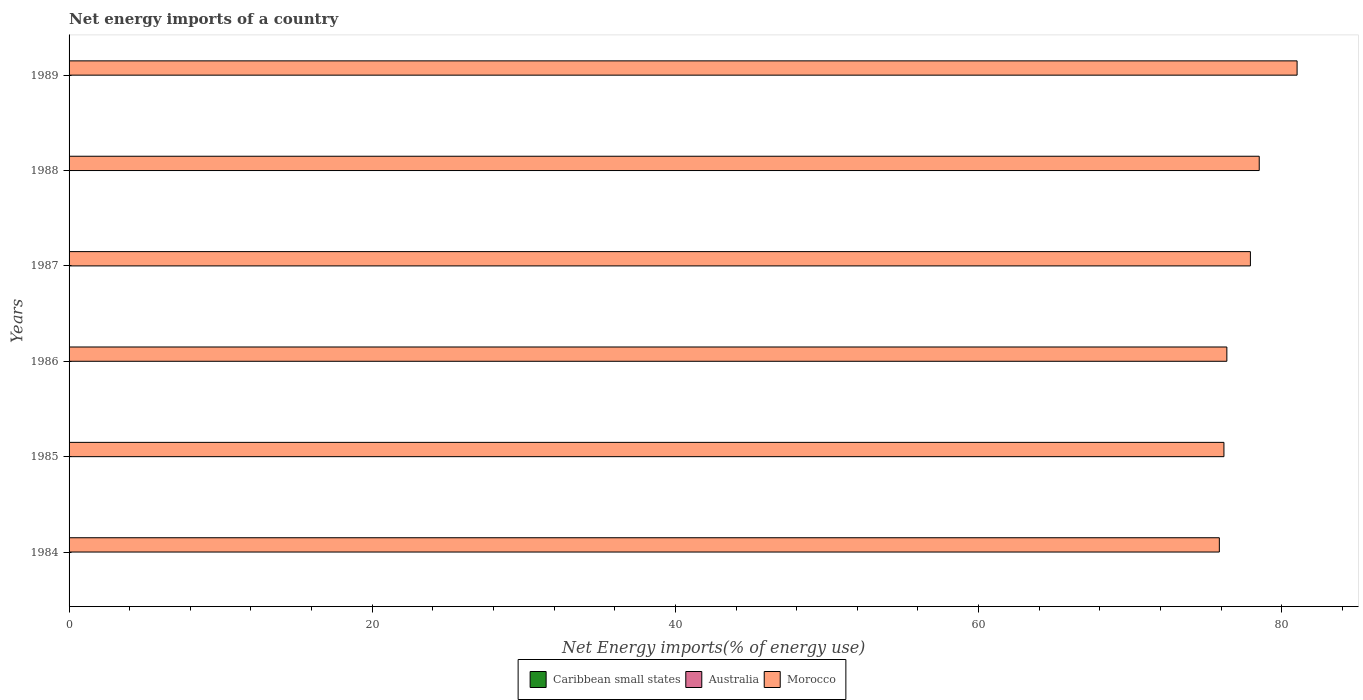How many different coloured bars are there?
Give a very brief answer. 1. Are the number of bars per tick equal to the number of legend labels?
Make the answer very short. No. Are the number of bars on each tick of the Y-axis equal?
Keep it short and to the point. Yes. How many bars are there on the 6th tick from the top?
Offer a terse response. 1. How many bars are there on the 4th tick from the bottom?
Keep it short and to the point. 1. What is the label of the 3rd group of bars from the top?
Give a very brief answer. 1987. What is the net energy imports in Caribbean small states in 1984?
Offer a terse response. 0. Across all years, what is the maximum net energy imports in Morocco?
Your answer should be compact. 81.02. Across all years, what is the minimum net energy imports in Australia?
Make the answer very short. 0. What is the total net energy imports in Australia in the graph?
Provide a succinct answer. 0. What is the difference between the net energy imports in Morocco in 1987 and that in 1988?
Provide a short and direct response. -0.58. What is the difference between the net energy imports in Caribbean small states in 1985 and the net energy imports in Australia in 1984?
Keep it short and to the point. 0. What is the average net energy imports in Australia per year?
Give a very brief answer. 0. What is the difference between the highest and the second highest net energy imports in Morocco?
Offer a terse response. 2.5. What is the difference between the highest and the lowest net energy imports in Morocco?
Your answer should be very brief. 5.13. In how many years, is the net energy imports in Morocco greater than the average net energy imports in Morocco taken over all years?
Offer a terse response. 3. How many years are there in the graph?
Make the answer very short. 6. What is the difference between two consecutive major ticks on the X-axis?
Your response must be concise. 20. What is the title of the graph?
Ensure brevity in your answer.  Net energy imports of a country. What is the label or title of the X-axis?
Your response must be concise. Net Energy imports(% of energy use). What is the Net Energy imports(% of energy use) of Caribbean small states in 1984?
Offer a very short reply. 0. What is the Net Energy imports(% of energy use) in Australia in 1984?
Make the answer very short. 0. What is the Net Energy imports(% of energy use) in Morocco in 1984?
Offer a terse response. 75.89. What is the Net Energy imports(% of energy use) in Morocco in 1985?
Give a very brief answer. 76.19. What is the Net Energy imports(% of energy use) in Morocco in 1986?
Offer a very short reply. 76.38. What is the Net Energy imports(% of energy use) in Caribbean small states in 1987?
Ensure brevity in your answer.  0. What is the Net Energy imports(% of energy use) in Australia in 1987?
Keep it short and to the point. 0. What is the Net Energy imports(% of energy use) in Morocco in 1987?
Provide a short and direct response. 77.94. What is the Net Energy imports(% of energy use) of Caribbean small states in 1988?
Provide a short and direct response. 0. What is the Net Energy imports(% of energy use) of Australia in 1988?
Your response must be concise. 0. What is the Net Energy imports(% of energy use) in Morocco in 1988?
Ensure brevity in your answer.  78.52. What is the Net Energy imports(% of energy use) in Caribbean small states in 1989?
Ensure brevity in your answer.  0. What is the Net Energy imports(% of energy use) of Morocco in 1989?
Offer a terse response. 81.02. Across all years, what is the maximum Net Energy imports(% of energy use) of Morocco?
Provide a short and direct response. 81.02. Across all years, what is the minimum Net Energy imports(% of energy use) of Morocco?
Provide a short and direct response. 75.89. What is the total Net Energy imports(% of energy use) in Caribbean small states in the graph?
Ensure brevity in your answer.  0. What is the total Net Energy imports(% of energy use) of Australia in the graph?
Your response must be concise. 0. What is the total Net Energy imports(% of energy use) in Morocco in the graph?
Your answer should be compact. 465.93. What is the difference between the Net Energy imports(% of energy use) of Morocco in 1984 and that in 1985?
Offer a very short reply. -0.3. What is the difference between the Net Energy imports(% of energy use) in Morocco in 1984 and that in 1986?
Your response must be concise. -0.5. What is the difference between the Net Energy imports(% of energy use) of Morocco in 1984 and that in 1987?
Provide a short and direct response. -2.05. What is the difference between the Net Energy imports(% of energy use) in Morocco in 1984 and that in 1988?
Provide a succinct answer. -2.63. What is the difference between the Net Energy imports(% of energy use) in Morocco in 1984 and that in 1989?
Provide a short and direct response. -5.13. What is the difference between the Net Energy imports(% of energy use) of Morocco in 1985 and that in 1986?
Give a very brief answer. -0.19. What is the difference between the Net Energy imports(% of energy use) of Morocco in 1985 and that in 1987?
Ensure brevity in your answer.  -1.75. What is the difference between the Net Energy imports(% of energy use) of Morocco in 1985 and that in 1988?
Provide a short and direct response. -2.33. What is the difference between the Net Energy imports(% of energy use) in Morocco in 1985 and that in 1989?
Provide a short and direct response. -4.83. What is the difference between the Net Energy imports(% of energy use) in Morocco in 1986 and that in 1987?
Your response must be concise. -1.55. What is the difference between the Net Energy imports(% of energy use) of Morocco in 1986 and that in 1988?
Offer a very short reply. -2.14. What is the difference between the Net Energy imports(% of energy use) of Morocco in 1986 and that in 1989?
Offer a terse response. -4.63. What is the difference between the Net Energy imports(% of energy use) in Morocco in 1987 and that in 1988?
Make the answer very short. -0.58. What is the difference between the Net Energy imports(% of energy use) in Morocco in 1987 and that in 1989?
Make the answer very short. -3.08. What is the difference between the Net Energy imports(% of energy use) of Morocco in 1988 and that in 1989?
Offer a very short reply. -2.5. What is the average Net Energy imports(% of energy use) in Caribbean small states per year?
Offer a terse response. 0. What is the average Net Energy imports(% of energy use) in Morocco per year?
Your response must be concise. 77.65. What is the ratio of the Net Energy imports(% of energy use) in Morocco in 1984 to that in 1985?
Your response must be concise. 1. What is the ratio of the Net Energy imports(% of energy use) in Morocco in 1984 to that in 1986?
Your response must be concise. 0.99. What is the ratio of the Net Energy imports(% of energy use) in Morocco in 1984 to that in 1987?
Ensure brevity in your answer.  0.97. What is the ratio of the Net Energy imports(% of energy use) of Morocco in 1984 to that in 1988?
Provide a short and direct response. 0.97. What is the ratio of the Net Energy imports(% of energy use) of Morocco in 1984 to that in 1989?
Your answer should be compact. 0.94. What is the ratio of the Net Energy imports(% of energy use) in Morocco in 1985 to that in 1987?
Offer a terse response. 0.98. What is the ratio of the Net Energy imports(% of energy use) of Morocco in 1985 to that in 1988?
Your answer should be compact. 0.97. What is the ratio of the Net Energy imports(% of energy use) in Morocco in 1985 to that in 1989?
Your answer should be compact. 0.94. What is the ratio of the Net Energy imports(% of energy use) of Morocco in 1986 to that in 1987?
Your answer should be very brief. 0.98. What is the ratio of the Net Energy imports(% of energy use) in Morocco in 1986 to that in 1988?
Your answer should be compact. 0.97. What is the ratio of the Net Energy imports(% of energy use) of Morocco in 1986 to that in 1989?
Your response must be concise. 0.94. What is the ratio of the Net Energy imports(% of energy use) in Morocco in 1987 to that in 1988?
Make the answer very short. 0.99. What is the ratio of the Net Energy imports(% of energy use) in Morocco in 1988 to that in 1989?
Your response must be concise. 0.97. What is the difference between the highest and the second highest Net Energy imports(% of energy use) of Morocco?
Offer a very short reply. 2.5. What is the difference between the highest and the lowest Net Energy imports(% of energy use) in Morocco?
Your answer should be compact. 5.13. 